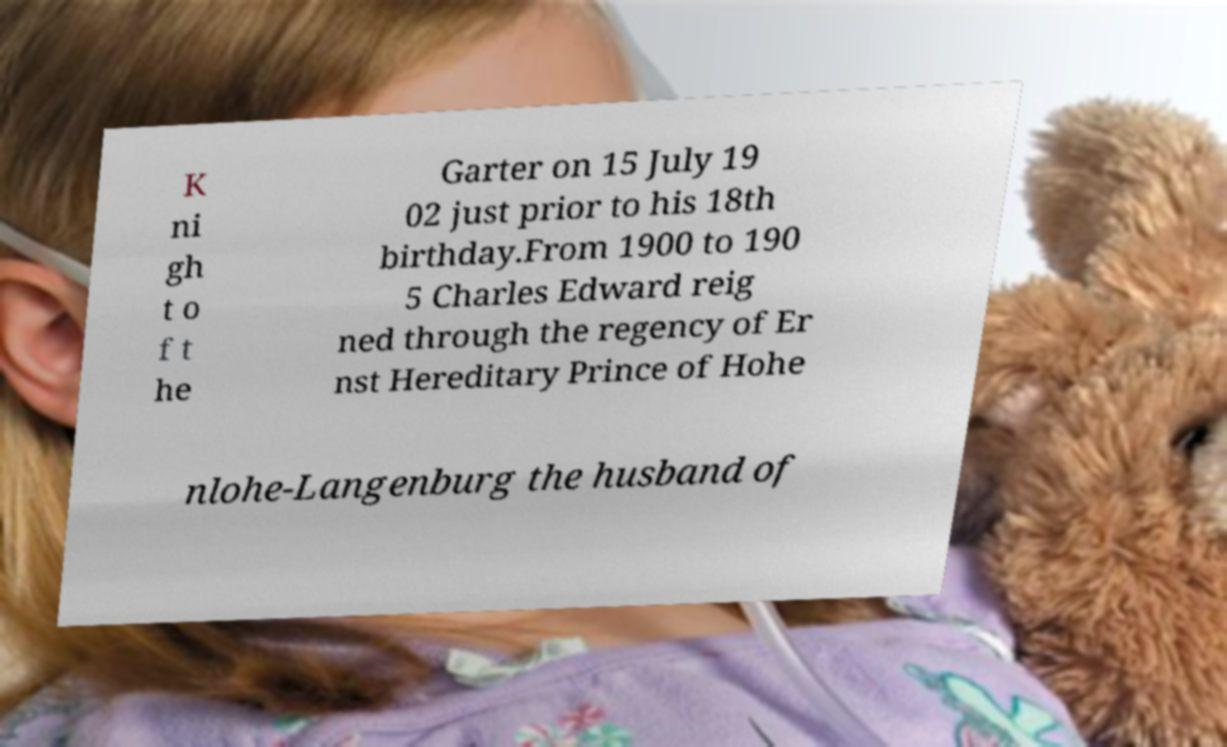Could you extract and type out the text from this image? K ni gh t o f t he Garter on 15 July 19 02 just prior to his 18th birthday.From 1900 to 190 5 Charles Edward reig ned through the regency of Er nst Hereditary Prince of Hohe nlohe-Langenburg the husband of 